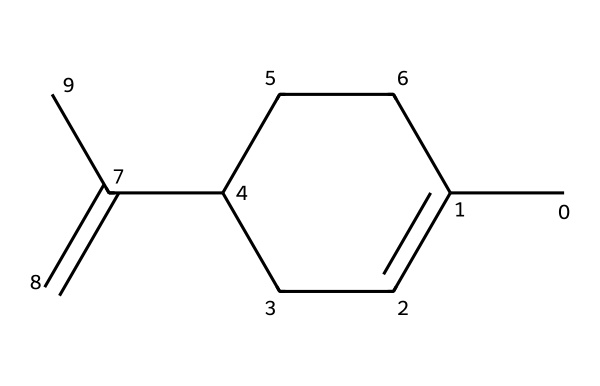How many carbon atoms are in limonene? By examining the SMILES representation, CC1=CCC(CC1)C(=C)C, we can identify the number of carbon (C) atoms. Counting each 'C' in the structure, we see there are 10 carbon atoms in total.
Answer: 10 How many double bonds does limonene have? In the SMILES representation, there are '=C' and '=' symbols indicating double bonds. By checking the structure carefully, we find that there are 2 double bonds present in limonene.
Answer: 2 What type of chemical structure is limonene classified as? Limonene, as represented in the SMILES, contains multiple carbon atoms and is characterized by its structure, which includes a ring and double bonds, classifying it as a terpene.
Answer: terpene What functional group is present in limonene? In the structure displayed in the SMILES, one can identify that limonene contains a carbon-carbon double bond (C=C), which is typical for alkenes. Thus, the functional group present is alkene.
Answer: alkene What is the primary scent profile of limonene? Based on the known properties of limonene and its common sources like citrus fruits, it is classified as having a citrus scent profile. This points directly to its aromatic quality as a flavor and fragrance.
Answer: citrus 